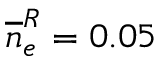<formula> <loc_0><loc_0><loc_500><loc_500>\overline { n } _ { e } ^ { R } = 0 . 0 5</formula> 